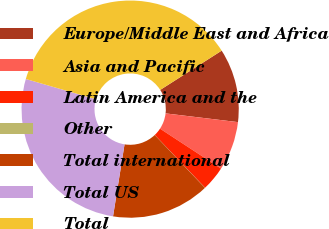Convert chart to OTSL. <chart><loc_0><loc_0><loc_500><loc_500><pie_chart><fcel>Europe/Middle East and Africa<fcel>Asia and Pacific<fcel>Latin America and the<fcel>Other<fcel>Total international<fcel>Total US<fcel>Total<nl><fcel>10.96%<fcel>7.31%<fcel>3.67%<fcel>0.02%<fcel>14.61%<fcel>26.95%<fcel>36.48%<nl></chart> 